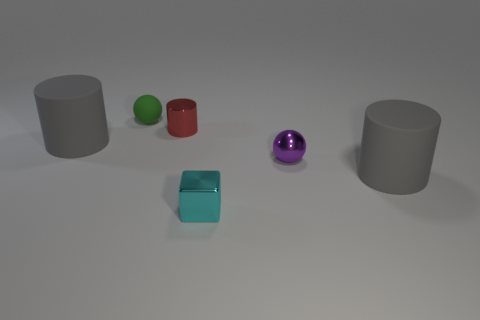Is the size of the metallic block the same as the metal ball?
Offer a terse response. Yes. What number of balls are green objects or tiny cyan objects?
Your answer should be very brief. 1. There is a sphere to the right of the small ball left of the red object; what is its color?
Make the answer very short. Purple. Are there fewer big rubber objects that are in front of the tiny metallic cube than small purple balls left of the tiny purple metallic ball?
Provide a short and direct response. No. There is a shiny cube; does it have the same size as the purple metal thing that is on the right side of the tiny green matte ball?
Provide a short and direct response. Yes. The small object that is both right of the tiny shiny cylinder and behind the cyan object has what shape?
Give a very brief answer. Sphere. There is a cyan thing that is made of the same material as the purple sphere; what is its size?
Provide a short and direct response. Small. There is a big rubber cylinder that is left of the green rubber thing; how many cyan cubes are on the right side of it?
Provide a short and direct response. 1. Do the large gray object to the right of the green matte thing and the small purple thing have the same material?
Give a very brief answer. No. Is there any other thing that is the same material as the cube?
Keep it short and to the point. Yes. 